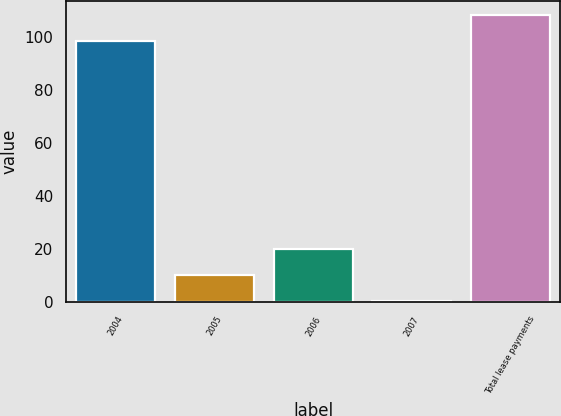Convert chart. <chart><loc_0><loc_0><loc_500><loc_500><bar_chart><fcel>2004<fcel>2005<fcel>2006<fcel>2007<fcel>Total lease payments<nl><fcel>98.4<fcel>9.98<fcel>19.86<fcel>0.1<fcel>108.28<nl></chart> 